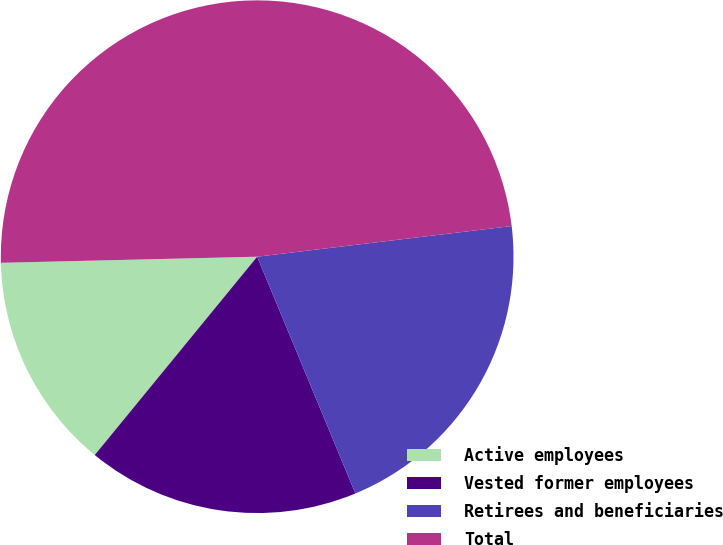<chart> <loc_0><loc_0><loc_500><loc_500><pie_chart><fcel>Active employees<fcel>Vested former employees<fcel>Retirees and beneficiaries<fcel>Total<nl><fcel>13.7%<fcel>17.18%<fcel>20.65%<fcel>48.47%<nl></chart> 